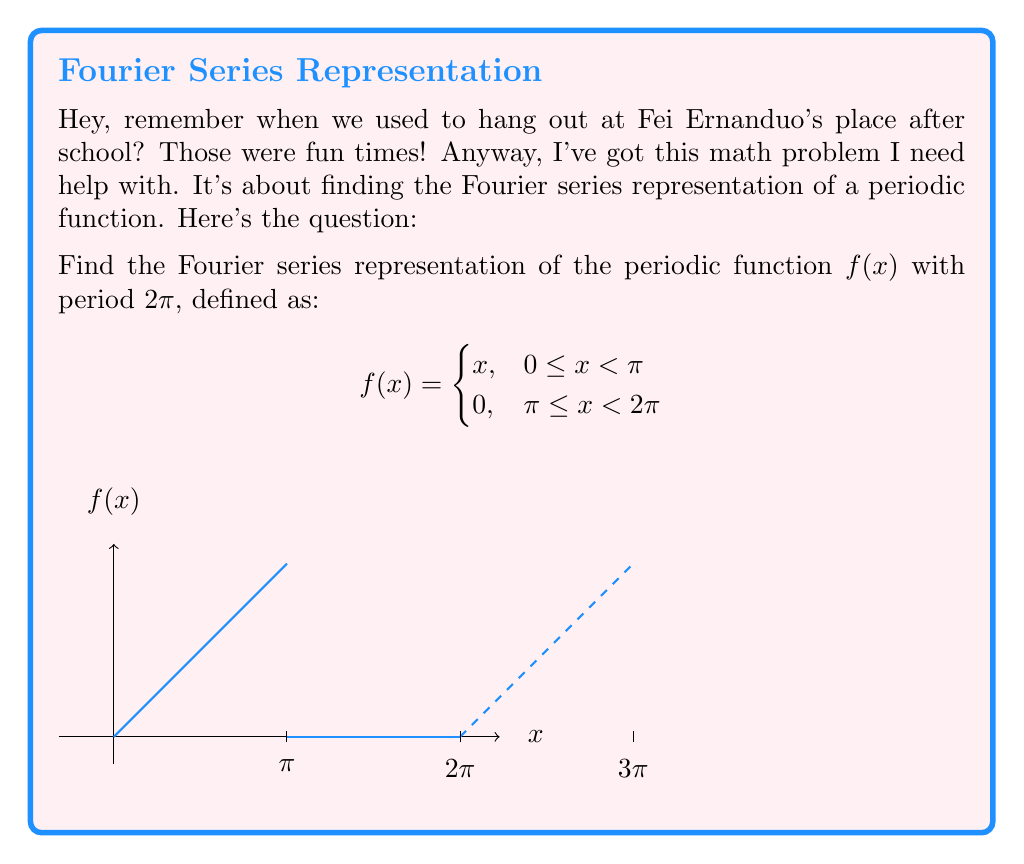Could you help me with this problem? Alright, let's break this down step-by-step:

1) The Fourier series of a function $f(x)$ with period $2\pi$ is given by:

   $$f(x) = \frac{a_0}{2} + \sum_{n=1}^{\infty} (a_n \cos(nx) + b_n \sin(nx))$$

   where $a_0$, $a_n$, and $b_n$ are Fourier coefficients.

2) To find these coefficients, we use the following formulas:

   $$a_0 = \frac{1}{\pi} \int_0^{2\pi} f(x) dx$$
   $$a_n = \frac{1}{\pi} \int_0^{2\pi} f(x) \cos(nx) dx$$
   $$b_n = \frac{1}{\pi} \int_0^{2\pi} f(x) \sin(nx) dx$$

3) Let's start with $a_0$:
   
   $$a_0 = \frac{1}{\pi} \left(\int_0^{\pi} x dx + \int_{\pi}^{2\pi} 0 dx\right) = \frac{1}{\pi} \left[\frac{x^2}{2}\right]_0^{\pi} = \frac{\pi}{2}$$

4) For $a_n$:
   
   $$a_n = \frac{1}{\pi} \int_0^{\pi} x \cos(nx) dx$$
   
   Integrating by parts:
   
   $$a_n = \frac{1}{\pi} \left[\frac{x\sin(nx)}{n}\right]_0^{\pi} - \frac{1}{\pi n} \int_0^{\pi} \sin(nx) dx$$
   $$= \frac{(-1)^n}{n} - \frac{1}{\pi n} \left[-\frac{\cos(nx)}{n}\right]_0^{\pi} = \frac{(-1)^n}{n} + \frac{1}{\pi n^2}((-1)^n - 1)$$

5) For $b_n$:
   
   $$b_n = \frac{1}{\pi} \int_0^{\pi} x \sin(nx) dx$$
   
   Integrating by parts:
   
   $$b_n = -\frac{1}{\pi n} \left[x\cos(nx)\right]_0^{\pi} + \frac{1}{\pi n} \int_0^{\pi} \cos(nx) dx$$
   $$= \frac{\pi}{n} + \frac{1}{\pi n^2} \sin(n\pi) = \frac{\pi}{n}$$

6) Therefore, the Fourier series representation is:

   $$f(x) = \frac{\pi}{4} + \sum_{n=1}^{\infty} \left(\frac{(-1)^n}{n} + \frac{1}{\pi n^2}((-1)^n - 1)\right)\cos(nx) + \frac{\pi}{n}\sin(nx)$$
Answer: $$f(x) = \frac{\pi}{4} + \sum_{n=1}^{\infty} \left(\frac{(-1)^n}{n} + \frac{1}{\pi n^2}((-1)^n - 1)\right)\cos(nx) + \frac{\pi}{n}\sin(nx)$$ 